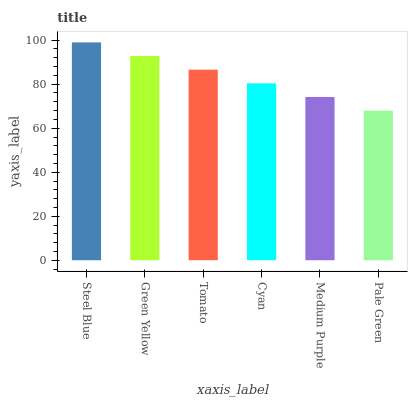Is Pale Green the minimum?
Answer yes or no. Yes. Is Steel Blue the maximum?
Answer yes or no. Yes. Is Green Yellow the minimum?
Answer yes or no. No. Is Green Yellow the maximum?
Answer yes or no. No. Is Steel Blue greater than Green Yellow?
Answer yes or no. Yes. Is Green Yellow less than Steel Blue?
Answer yes or no. Yes. Is Green Yellow greater than Steel Blue?
Answer yes or no. No. Is Steel Blue less than Green Yellow?
Answer yes or no. No. Is Tomato the high median?
Answer yes or no. Yes. Is Cyan the low median?
Answer yes or no. Yes. Is Pale Green the high median?
Answer yes or no. No. Is Medium Purple the low median?
Answer yes or no. No. 